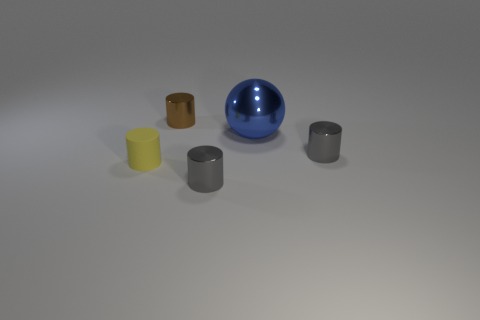There is a gray thing that is in front of the small gray metal object that is behind the small yellow object; are there any tiny metallic cylinders right of it?
Your response must be concise. Yes. Does the small yellow thing on the left side of the big ball have the same shape as the big blue object?
Give a very brief answer. No. The ball that is made of the same material as the small brown cylinder is what color?
Your answer should be very brief. Blue. What number of tiny gray things are made of the same material as the large blue object?
Make the answer very short. 2. There is a shiny sphere that is behind the small gray cylinder that is behind the metal cylinder that is in front of the tiny matte cylinder; what is its color?
Offer a terse response. Blue. Is the size of the shiny sphere the same as the yellow cylinder?
Provide a short and direct response. No. Are there any other things that are the same shape as the big thing?
Offer a very short reply. No. How many objects are small cylinders in front of the tiny brown cylinder or tiny metallic things?
Your answer should be very brief. 4. Does the big shiny object have the same shape as the brown metal object?
Your response must be concise. No. What number of other things are there of the same size as the blue thing?
Offer a very short reply. 0. 